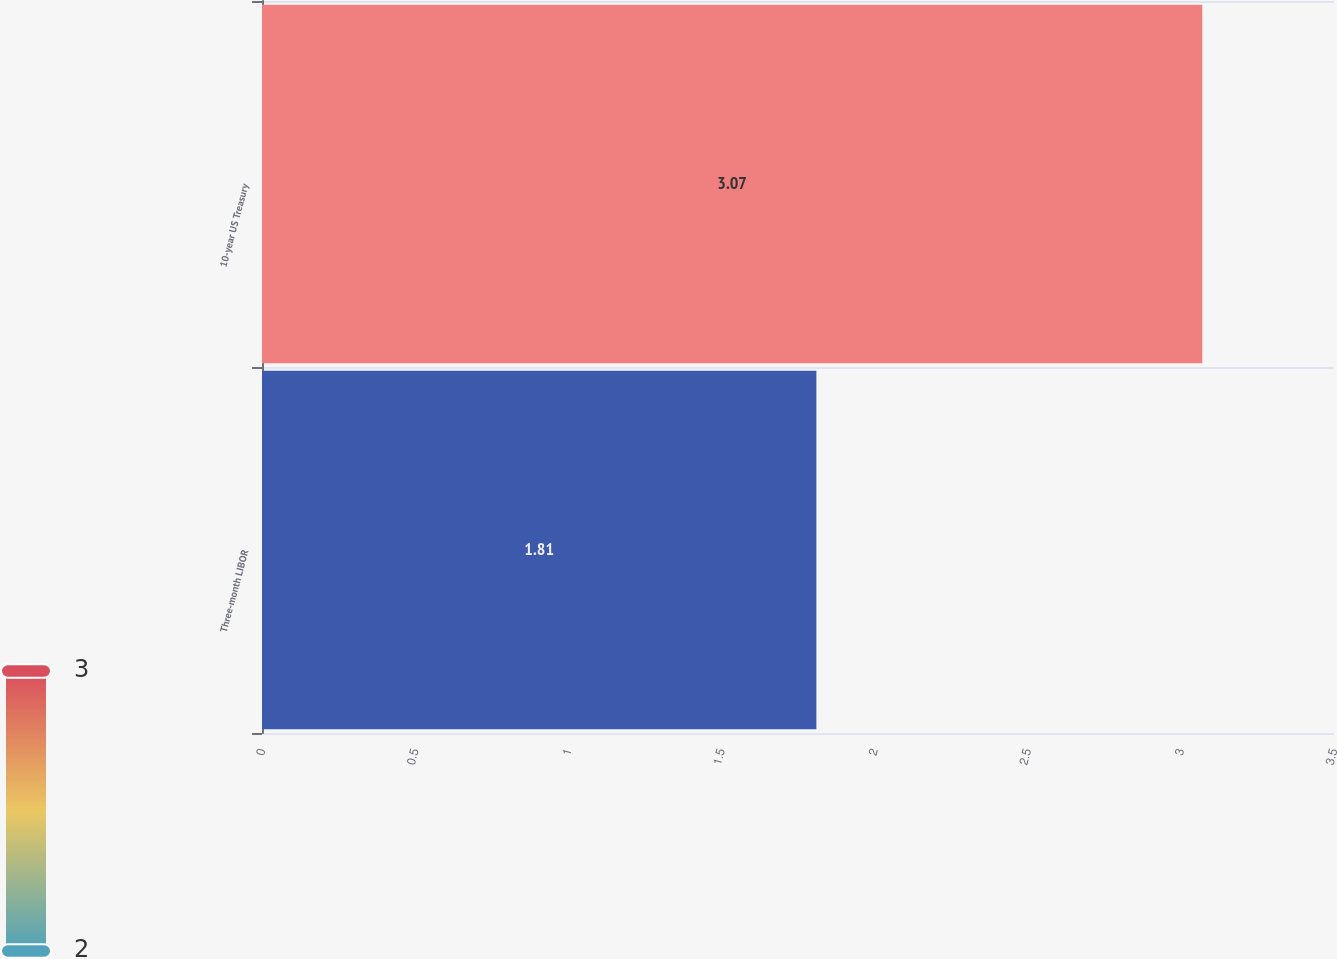<chart> <loc_0><loc_0><loc_500><loc_500><bar_chart><fcel>Three-month LIBOR<fcel>10-year US Treasury<nl><fcel>1.81<fcel>3.07<nl></chart> 